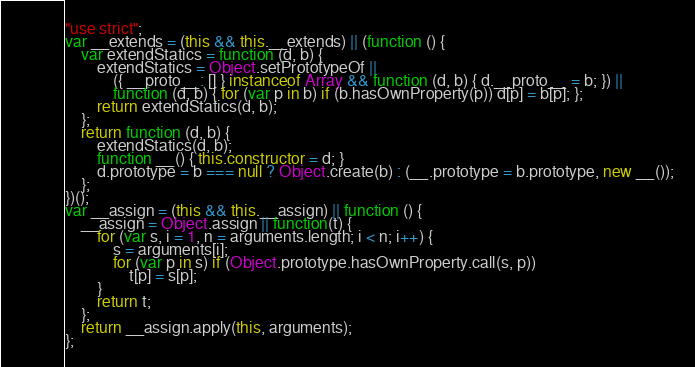Convert code to text. <code><loc_0><loc_0><loc_500><loc_500><_JavaScript_>"use strict";
var __extends = (this && this.__extends) || (function () {
    var extendStatics = function (d, b) {
        extendStatics = Object.setPrototypeOf ||
            ({ __proto__: [] } instanceof Array && function (d, b) { d.__proto__ = b; }) ||
            function (d, b) { for (var p in b) if (b.hasOwnProperty(p)) d[p] = b[p]; };
        return extendStatics(d, b);
    };
    return function (d, b) {
        extendStatics(d, b);
        function __() { this.constructor = d; }
        d.prototype = b === null ? Object.create(b) : (__.prototype = b.prototype, new __());
    };
})();
var __assign = (this && this.__assign) || function () {
    __assign = Object.assign || function(t) {
        for (var s, i = 1, n = arguments.length; i < n; i++) {
            s = arguments[i];
            for (var p in s) if (Object.prototype.hasOwnProperty.call(s, p))
                t[p] = s[p];
        }
        return t;
    };
    return __assign.apply(this, arguments);
};</code> 